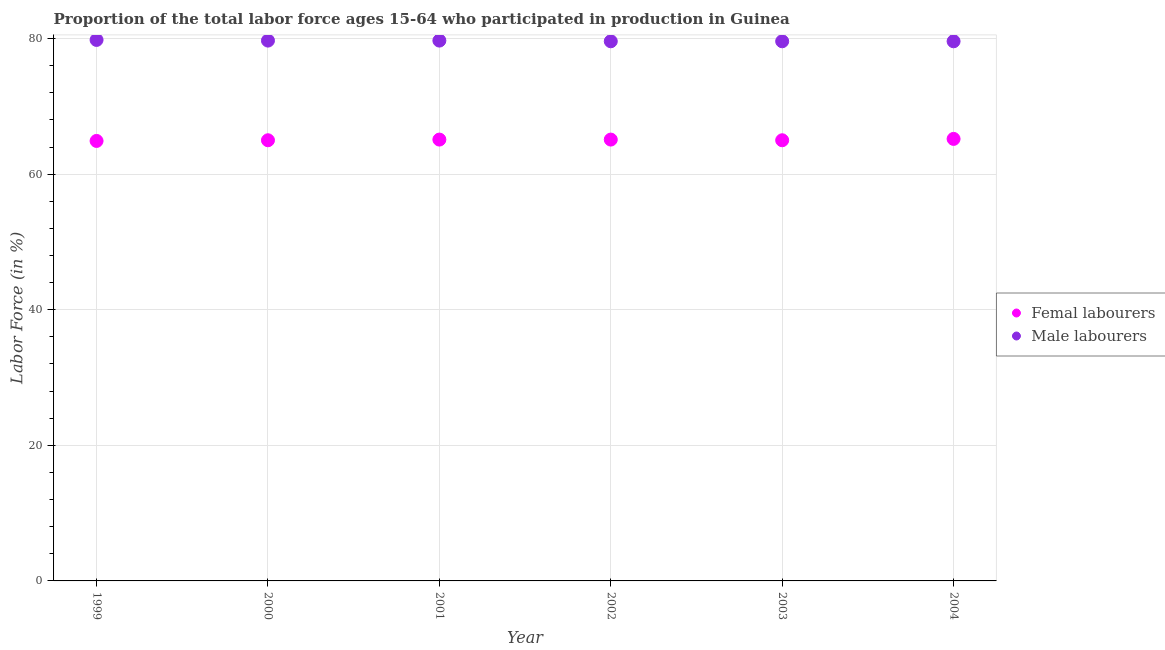How many different coloured dotlines are there?
Offer a very short reply. 2. What is the percentage of male labour force in 2004?
Provide a succinct answer. 79.6. Across all years, what is the maximum percentage of male labour force?
Provide a short and direct response. 79.8. Across all years, what is the minimum percentage of female labor force?
Provide a succinct answer. 64.9. In which year was the percentage of female labor force maximum?
Offer a terse response. 2004. What is the total percentage of female labor force in the graph?
Offer a terse response. 390.3. What is the difference between the percentage of male labour force in 2000 and that in 2001?
Ensure brevity in your answer.  0. What is the difference between the percentage of male labour force in 1999 and the percentage of female labor force in 2002?
Your response must be concise. 14.7. What is the average percentage of male labour force per year?
Offer a terse response. 79.67. In the year 1999, what is the difference between the percentage of male labour force and percentage of female labor force?
Your answer should be compact. 14.9. What is the ratio of the percentage of male labour force in 1999 to that in 2001?
Provide a succinct answer. 1. Is the percentage of female labor force in 2001 less than that in 2003?
Provide a succinct answer. No. Is the difference between the percentage of male labour force in 2000 and 2001 greater than the difference between the percentage of female labor force in 2000 and 2001?
Provide a short and direct response. Yes. What is the difference between the highest and the second highest percentage of female labor force?
Give a very brief answer. 0.1. What is the difference between the highest and the lowest percentage of male labour force?
Provide a short and direct response. 0.2. Is the percentage of female labor force strictly less than the percentage of male labour force over the years?
Offer a very short reply. Yes. What is the difference between two consecutive major ticks on the Y-axis?
Your response must be concise. 20. Are the values on the major ticks of Y-axis written in scientific E-notation?
Your response must be concise. No. Does the graph contain any zero values?
Provide a succinct answer. No. Does the graph contain grids?
Provide a succinct answer. Yes. What is the title of the graph?
Keep it short and to the point. Proportion of the total labor force ages 15-64 who participated in production in Guinea. What is the Labor Force (in %) in Femal labourers in 1999?
Make the answer very short. 64.9. What is the Labor Force (in %) in Male labourers in 1999?
Provide a short and direct response. 79.8. What is the Labor Force (in %) in Femal labourers in 2000?
Give a very brief answer. 65. What is the Labor Force (in %) of Male labourers in 2000?
Provide a succinct answer. 79.7. What is the Labor Force (in %) of Femal labourers in 2001?
Make the answer very short. 65.1. What is the Labor Force (in %) of Male labourers in 2001?
Offer a very short reply. 79.7. What is the Labor Force (in %) in Femal labourers in 2002?
Offer a very short reply. 65.1. What is the Labor Force (in %) in Male labourers in 2002?
Offer a terse response. 79.6. What is the Labor Force (in %) of Femal labourers in 2003?
Provide a short and direct response. 65. What is the Labor Force (in %) of Male labourers in 2003?
Your answer should be very brief. 79.6. What is the Labor Force (in %) of Femal labourers in 2004?
Give a very brief answer. 65.2. What is the Labor Force (in %) of Male labourers in 2004?
Provide a succinct answer. 79.6. Across all years, what is the maximum Labor Force (in %) in Femal labourers?
Provide a short and direct response. 65.2. Across all years, what is the maximum Labor Force (in %) of Male labourers?
Offer a very short reply. 79.8. Across all years, what is the minimum Labor Force (in %) in Femal labourers?
Your response must be concise. 64.9. Across all years, what is the minimum Labor Force (in %) of Male labourers?
Keep it short and to the point. 79.6. What is the total Labor Force (in %) of Femal labourers in the graph?
Offer a terse response. 390.3. What is the total Labor Force (in %) of Male labourers in the graph?
Keep it short and to the point. 478. What is the difference between the Labor Force (in %) in Male labourers in 1999 and that in 2000?
Offer a very short reply. 0.1. What is the difference between the Labor Force (in %) of Male labourers in 1999 and that in 2001?
Ensure brevity in your answer.  0.1. What is the difference between the Labor Force (in %) in Male labourers in 1999 and that in 2002?
Your response must be concise. 0.2. What is the difference between the Labor Force (in %) in Male labourers in 2000 and that in 2001?
Give a very brief answer. 0. What is the difference between the Labor Force (in %) in Femal labourers in 2000 and that in 2002?
Make the answer very short. -0.1. What is the difference between the Labor Force (in %) in Male labourers in 2000 and that in 2003?
Keep it short and to the point. 0.1. What is the difference between the Labor Force (in %) of Male labourers in 2001 and that in 2002?
Ensure brevity in your answer.  0.1. What is the difference between the Labor Force (in %) of Femal labourers in 2001 and that in 2003?
Provide a short and direct response. 0.1. What is the difference between the Labor Force (in %) of Male labourers in 2001 and that in 2003?
Your response must be concise. 0.1. What is the difference between the Labor Force (in %) of Femal labourers in 1999 and the Labor Force (in %) of Male labourers in 2000?
Make the answer very short. -14.8. What is the difference between the Labor Force (in %) of Femal labourers in 1999 and the Labor Force (in %) of Male labourers in 2001?
Provide a succinct answer. -14.8. What is the difference between the Labor Force (in %) of Femal labourers in 1999 and the Labor Force (in %) of Male labourers in 2002?
Your response must be concise. -14.7. What is the difference between the Labor Force (in %) of Femal labourers in 1999 and the Labor Force (in %) of Male labourers in 2003?
Make the answer very short. -14.7. What is the difference between the Labor Force (in %) in Femal labourers in 1999 and the Labor Force (in %) in Male labourers in 2004?
Give a very brief answer. -14.7. What is the difference between the Labor Force (in %) of Femal labourers in 2000 and the Labor Force (in %) of Male labourers in 2001?
Offer a very short reply. -14.7. What is the difference between the Labor Force (in %) in Femal labourers in 2000 and the Labor Force (in %) in Male labourers in 2002?
Your answer should be very brief. -14.6. What is the difference between the Labor Force (in %) in Femal labourers in 2000 and the Labor Force (in %) in Male labourers in 2003?
Give a very brief answer. -14.6. What is the difference between the Labor Force (in %) of Femal labourers in 2000 and the Labor Force (in %) of Male labourers in 2004?
Your answer should be compact. -14.6. What is the difference between the Labor Force (in %) in Femal labourers in 2001 and the Labor Force (in %) in Male labourers in 2002?
Give a very brief answer. -14.5. What is the difference between the Labor Force (in %) in Femal labourers in 2001 and the Labor Force (in %) in Male labourers in 2004?
Offer a terse response. -14.5. What is the difference between the Labor Force (in %) in Femal labourers in 2002 and the Labor Force (in %) in Male labourers in 2003?
Ensure brevity in your answer.  -14.5. What is the difference between the Labor Force (in %) in Femal labourers in 2003 and the Labor Force (in %) in Male labourers in 2004?
Your answer should be compact. -14.6. What is the average Labor Force (in %) in Femal labourers per year?
Offer a terse response. 65.05. What is the average Labor Force (in %) of Male labourers per year?
Your answer should be compact. 79.67. In the year 1999, what is the difference between the Labor Force (in %) in Femal labourers and Labor Force (in %) in Male labourers?
Provide a succinct answer. -14.9. In the year 2000, what is the difference between the Labor Force (in %) of Femal labourers and Labor Force (in %) of Male labourers?
Make the answer very short. -14.7. In the year 2001, what is the difference between the Labor Force (in %) of Femal labourers and Labor Force (in %) of Male labourers?
Offer a terse response. -14.6. In the year 2002, what is the difference between the Labor Force (in %) of Femal labourers and Labor Force (in %) of Male labourers?
Your answer should be compact. -14.5. In the year 2003, what is the difference between the Labor Force (in %) in Femal labourers and Labor Force (in %) in Male labourers?
Ensure brevity in your answer.  -14.6. In the year 2004, what is the difference between the Labor Force (in %) of Femal labourers and Labor Force (in %) of Male labourers?
Ensure brevity in your answer.  -14.4. What is the ratio of the Labor Force (in %) in Femal labourers in 1999 to that in 2002?
Your response must be concise. 1. What is the ratio of the Labor Force (in %) of Male labourers in 2000 to that in 2001?
Give a very brief answer. 1. What is the ratio of the Labor Force (in %) of Male labourers in 2000 to that in 2002?
Offer a very short reply. 1. What is the ratio of the Labor Force (in %) in Male labourers in 2000 to that in 2003?
Give a very brief answer. 1. What is the ratio of the Labor Force (in %) in Femal labourers in 2000 to that in 2004?
Provide a short and direct response. 1. What is the ratio of the Labor Force (in %) in Male labourers in 2000 to that in 2004?
Your answer should be compact. 1. What is the ratio of the Labor Force (in %) of Male labourers in 2001 to that in 2002?
Your answer should be compact. 1. What is the ratio of the Labor Force (in %) in Femal labourers in 2001 to that in 2003?
Give a very brief answer. 1. What is the ratio of the Labor Force (in %) in Male labourers in 2001 to that in 2004?
Your response must be concise. 1. What is the ratio of the Labor Force (in %) of Femal labourers in 2002 to that in 2003?
Give a very brief answer. 1. What is the ratio of the Labor Force (in %) of Male labourers in 2002 to that in 2003?
Ensure brevity in your answer.  1. What is the ratio of the Labor Force (in %) of Femal labourers in 2002 to that in 2004?
Offer a very short reply. 1. What is the ratio of the Labor Force (in %) of Male labourers in 2002 to that in 2004?
Ensure brevity in your answer.  1. What is the difference between the highest and the second highest Labor Force (in %) in Femal labourers?
Your answer should be compact. 0.1. What is the difference between the highest and the second highest Labor Force (in %) of Male labourers?
Provide a short and direct response. 0.1. What is the difference between the highest and the lowest Labor Force (in %) of Male labourers?
Give a very brief answer. 0.2. 